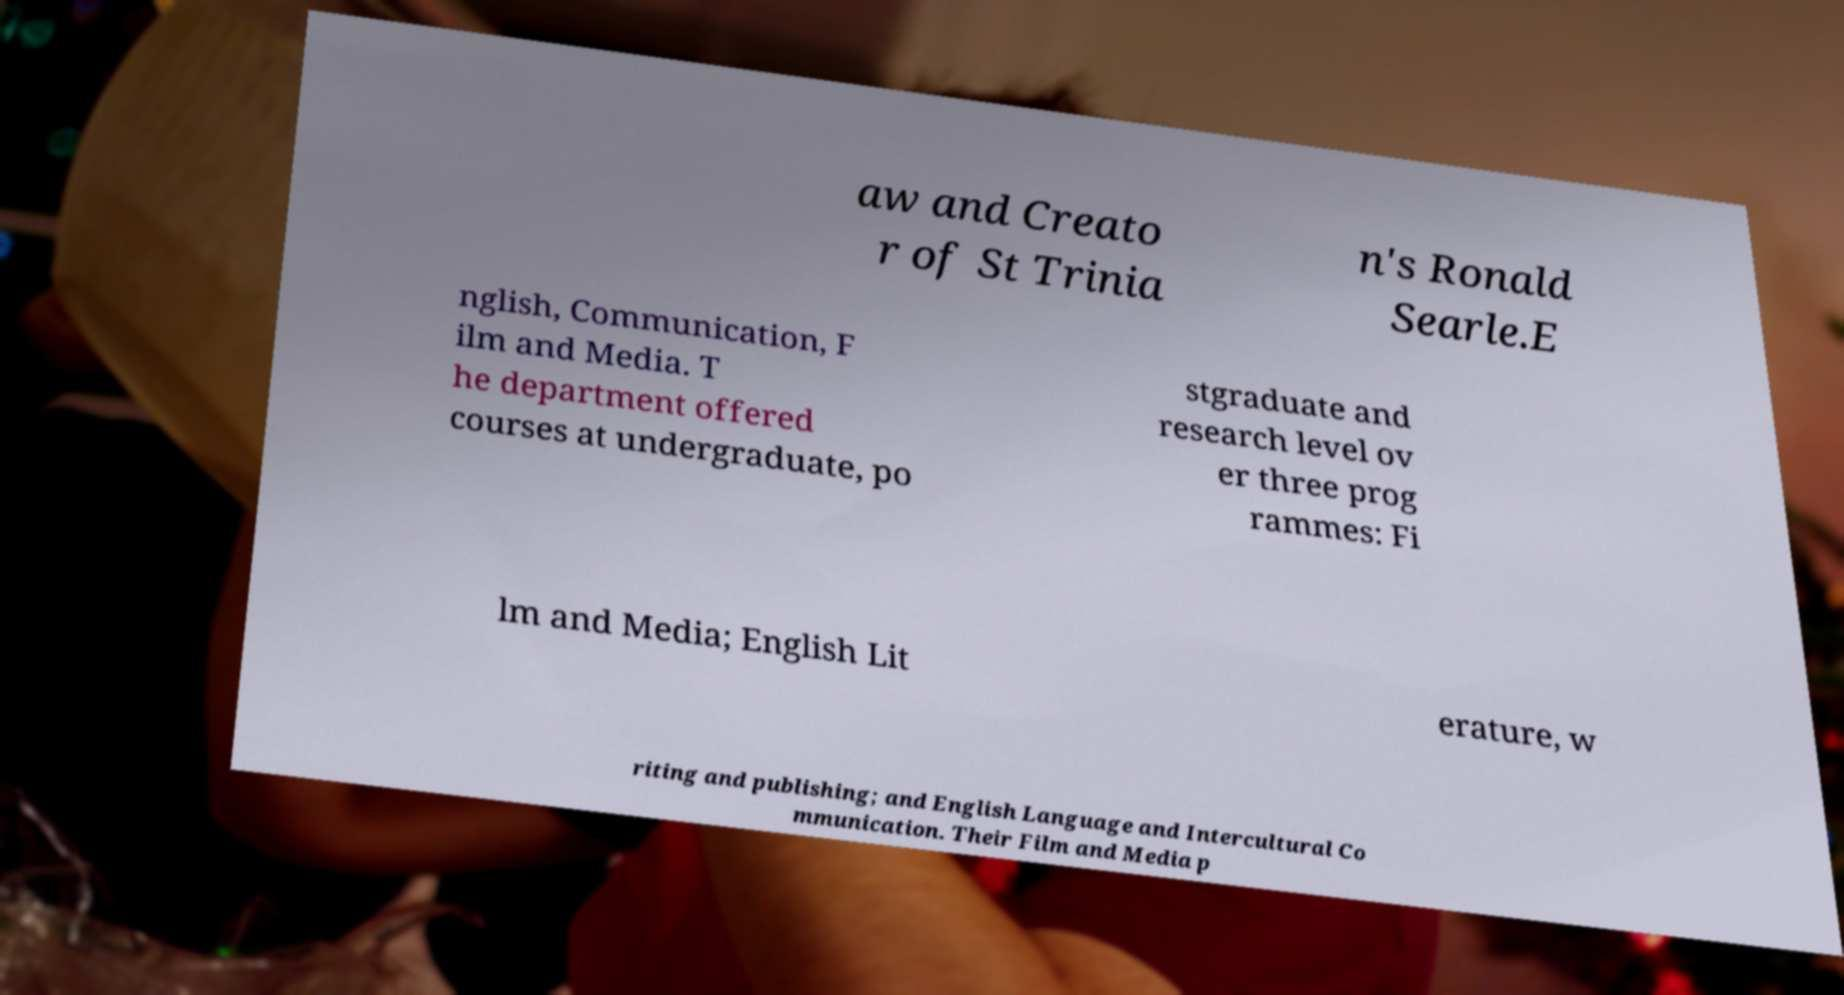Please read and relay the text visible in this image. What does it say? aw and Creato r of St Trinia n's Ronald Searle.E nglish, Communication, F ilm and Media. T he department offered courses at undergraduate, po stgraduate and research level ov er three prog rammes: Fi lm and Media; English Lit erature, w riting and publishing; and English Language and Intercultural Co mmunication. Their Film and Media p 